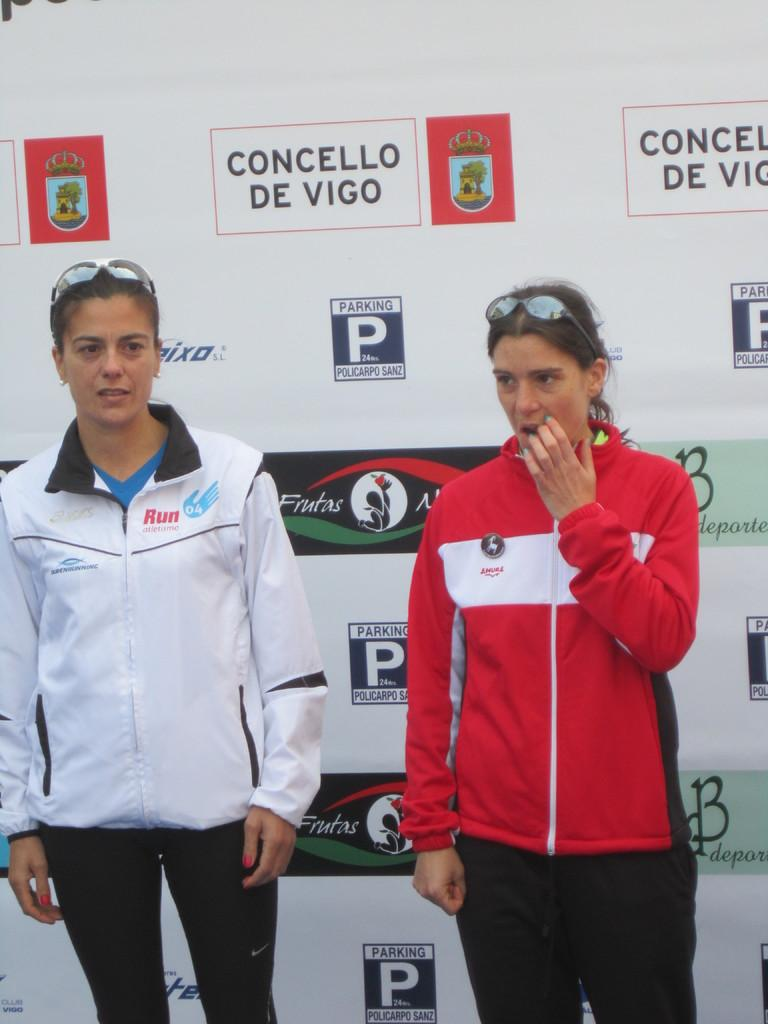<image>
Write a terse but informative summary of the picture. 04 is the number shown on the top of the person on the left. 